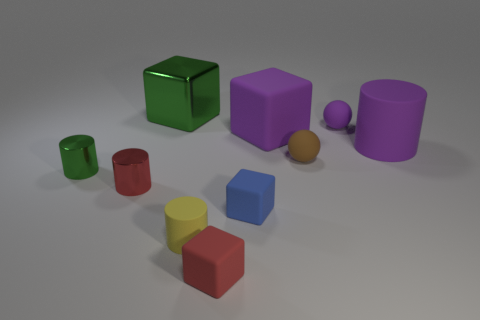Subtract all brown cubes. Subtract all purple balls. How many cubes are left? 4 Subtract all cylinders. How many objects are left? 6 Add 5 green metallic things. How many green metallic things are left? 7 Add 4 red metal objects. How many red metal objects exist? 5 Subtract 1 brown spheres. How many objects are left? 9 Subtract all red cylinders. Subtract all purple matte cubes. How many objects are left? 8 